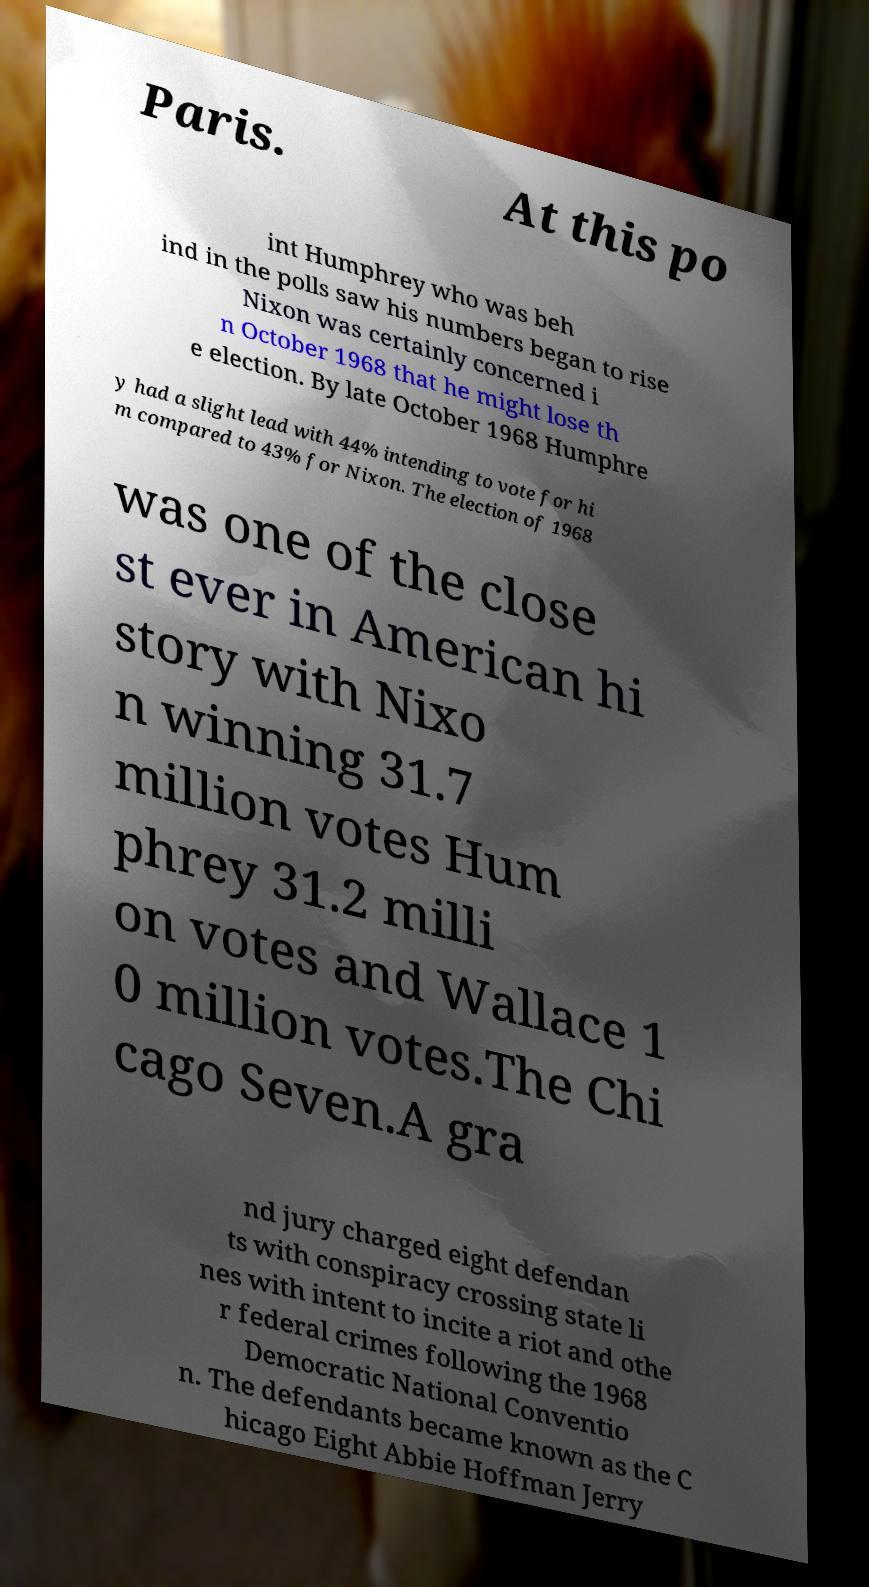Can you accurately transcribe the text from the provided image for me? Paris. At this po int Humphrey who was beh ind in the polls saw his numbers began to rise Nixon was certainly concerned i n October 1968 that he might lose th e election. By late October 1968 Humphre y had a slight lead with 44% intending to vote for hi m compared to 43% for Nixon. The election of 1968 was one of the close st ever in American hi story with Nixo n winning 31.7 million votes Hum phrey 31.2 milli on votes and Wallace 1 0 million votes.The Chi cago Seven.A gra nd jury charged eight defendan ts with conspiracy crossing state li nes with intent to incite a riot and othe r federal crimes following the 1968 Democratic National Conventio n. The defendants became known as the C hicago Eight Abbie Hoffman Jerry 